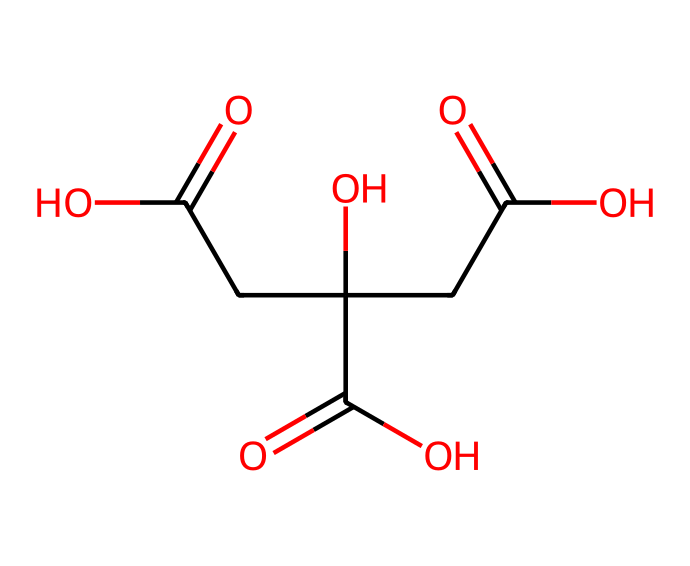What is the chemical name for this structure? The provided SMILES represents citric acid, which is a known organic acid commonly found in citrus fruits.
Answer: citric acid How many carbon atoms are present in citric acid? By analyzing the SMILES notation, there are 6 carbon atoms denoted by "C" in the structure.
Answer: 6 What is the total number of oxygen atoms in citric acid? The SMILES notation includes 7 oxygen atoms shown as "O" in various parts of the structure, indicating the total count.
Answer: 7 Is citric acid a strong or weak acid? Citric acid is considered a weak acid, which means it does not fully dissociate in solution. This is generally characterized by its three carboxylic acid groups, but it maintains equilibrium in solution.
Answer: weak What functional groups are present in citric acid? The structure contains three carboxylic acid (-COOH) groups, which are characteristic functional groups for acids. This group is responsible for the acidic properties of citric acid.
Answer: carboxylic acid How many hydrogen atoms are in citric acid? Counting the hydrogen atoms associated with each carbon and the carboxylic groups from the SMILES, there are 8 hydrogen atoms present in total.
Answer: 8 What is the primary role of citric acid in sports drinks? Citric acid in sports drinks primarily serves as a flavoring agent and helps in maintaining the acidity, which can aid in hydration and electrolyte balance.
Answer: flavoring agent 